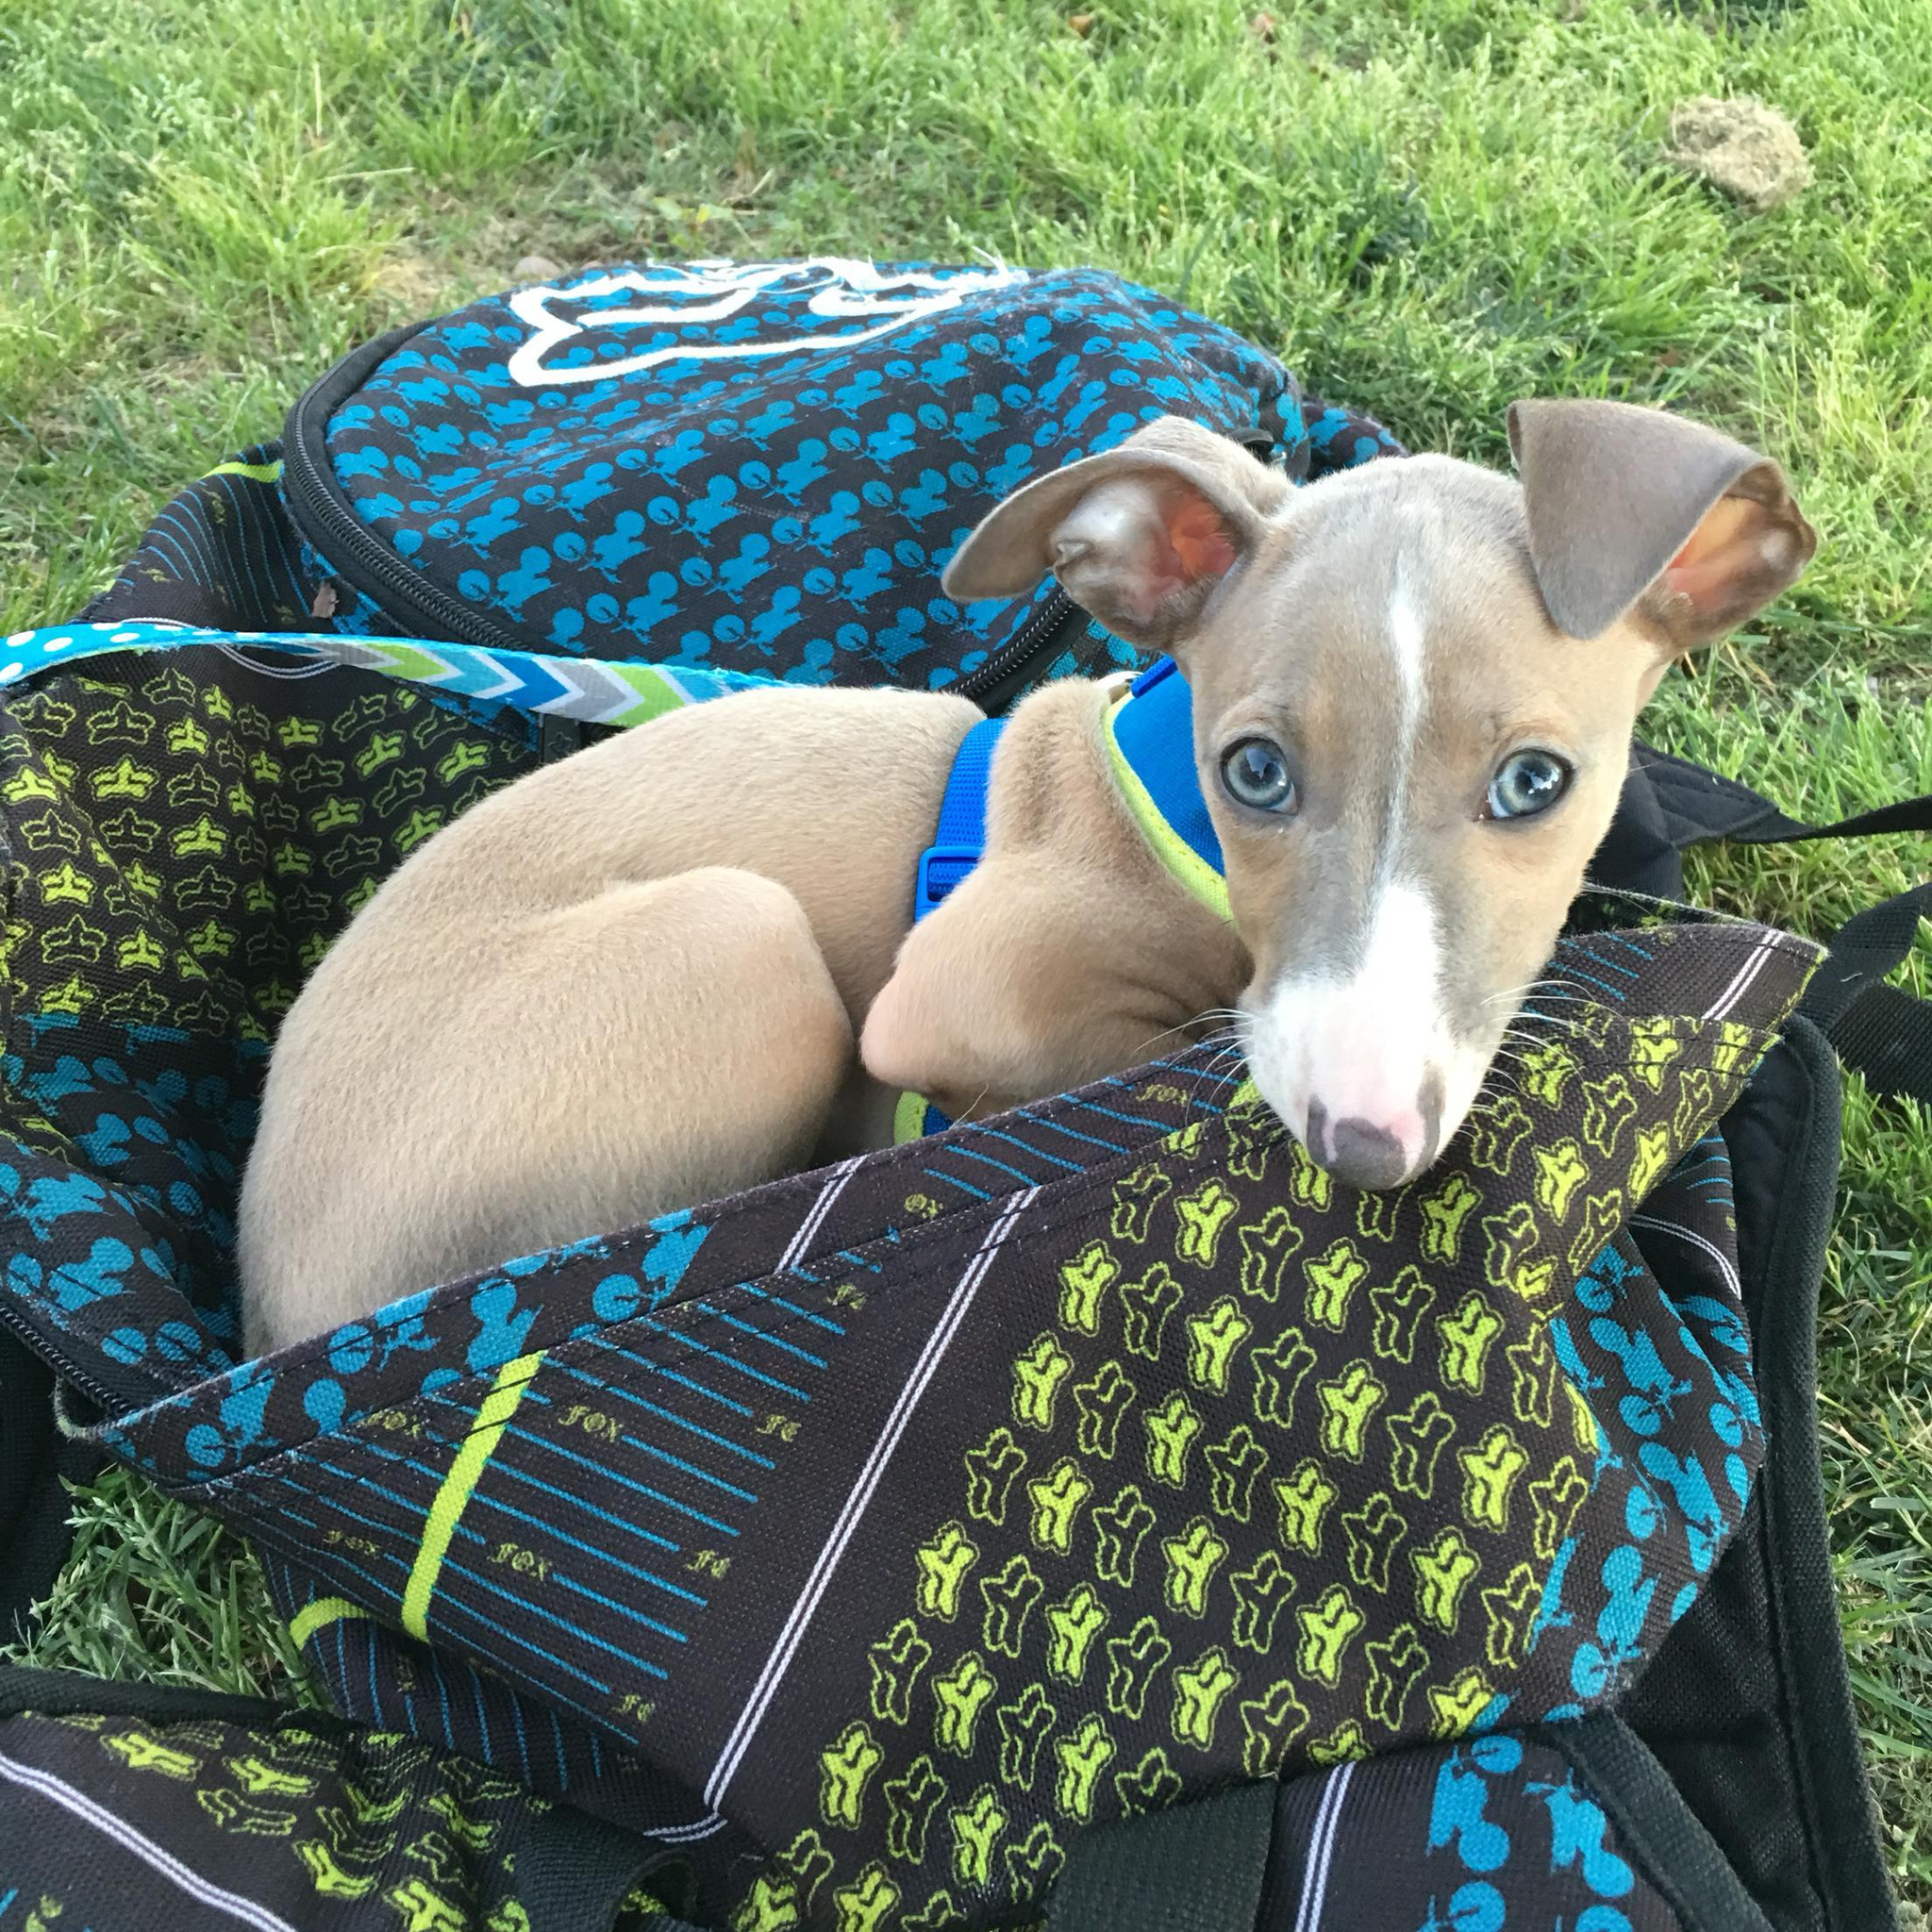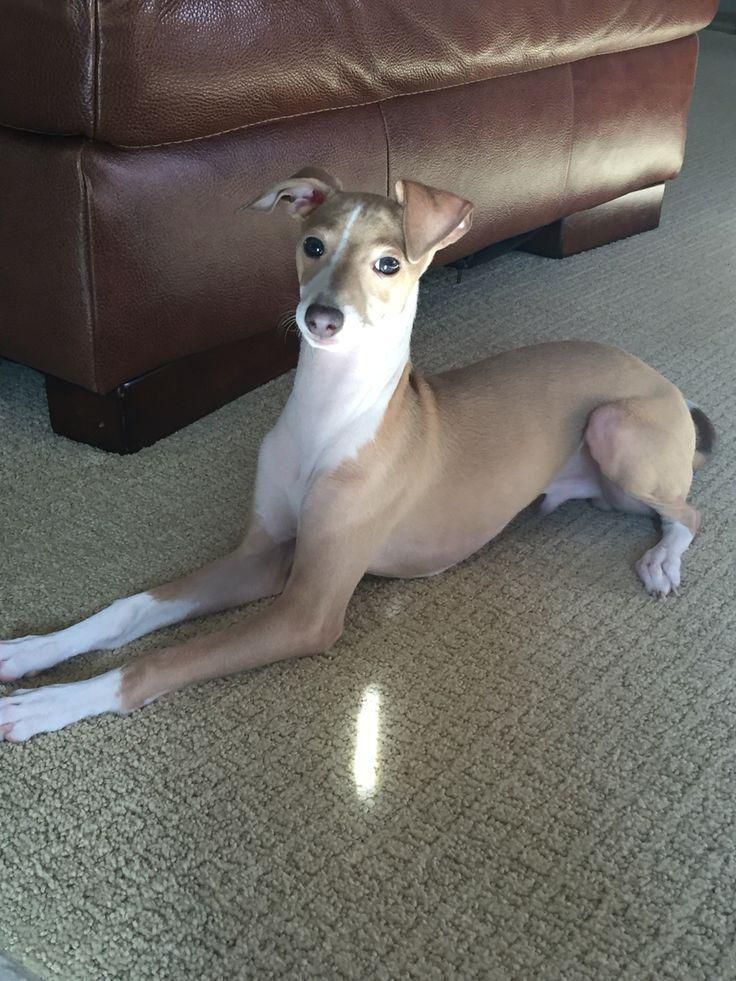The first image is the image on the left, the second image is the image on the right. Examine the images to the left and right. Is the description "A gray puppy with white paws is standing in front of another puppy in one image." accurate? Answer yes or no. No. The first image is the image on the left, the second image is the image on the right. Given the left and right images, does the statement "There is at least one dog outside in the image on the left." hold true? Answer yes or no. Yes. 